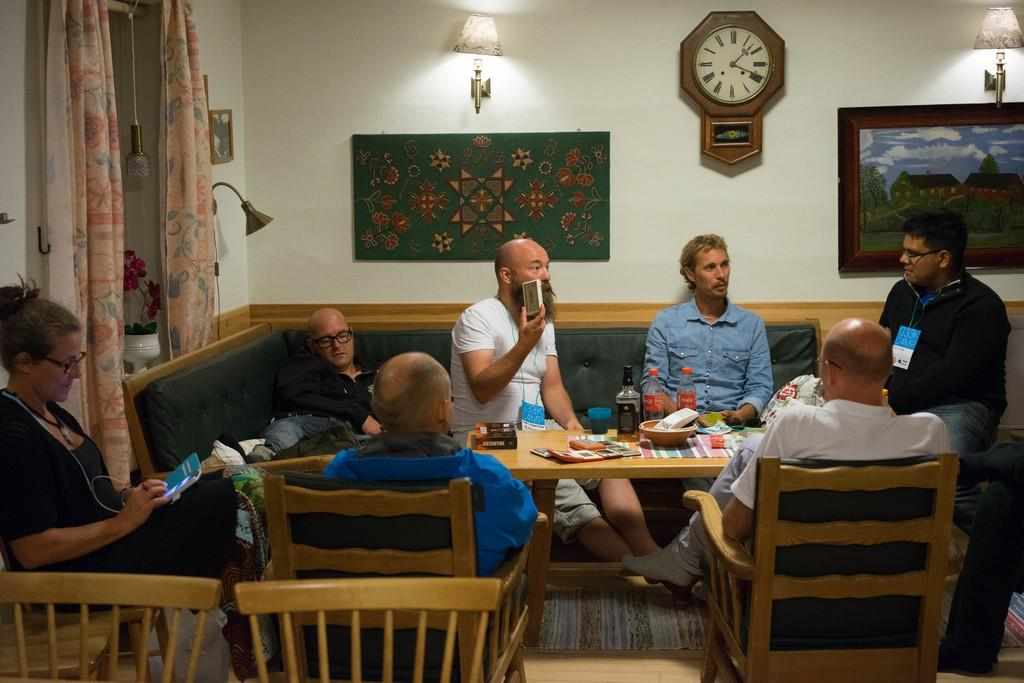What are the people in the image doing? The people in the image are sitting on a sofa. What is located near the sofa in the image? There is a table in the image. What can be seen on the table in the image? There is a wine bottle, juice bottles, and food items on the table. Where is the coat hanging in the image? There is no coat present in the image. What type of chalk is being used to draw on the wall in the image? There is no chalk or drawing on the wall in the image. 